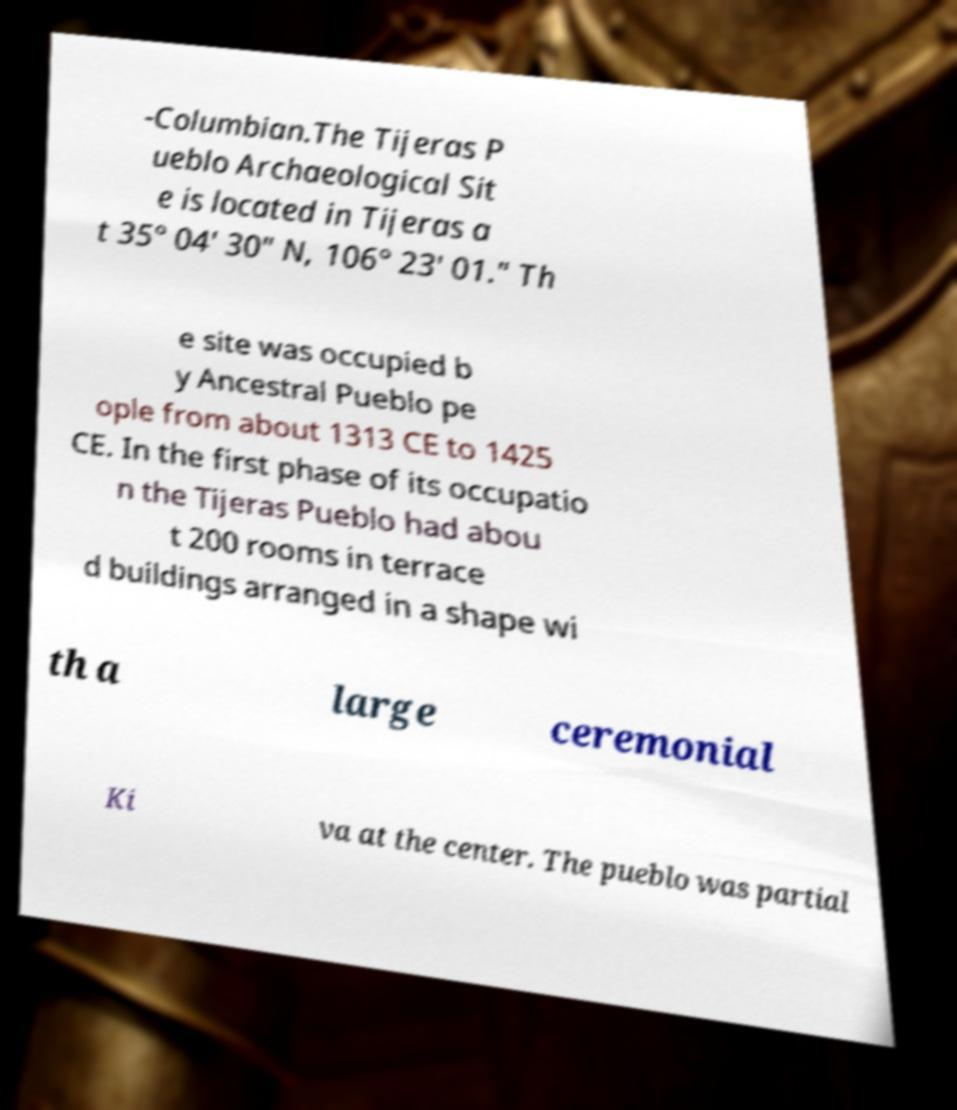Could you extract and type out the text from this image? -Columbian.The Tijeras P ueblo Archaeological Sit e is located in Tijeras a t 35° 04′ 30″ N, 106° 23′ 01.″ Th e site was occupied b y Ancestral Pueblo pe ople from about 1313 CE to 1425 CE. In the first phase of its occupatio n the Tijeras Pueblo had abou t 200 rooms in terrace d buildings arranged in a shape wi th a large ceremonial Ki va at the center. The pueblo was partial 